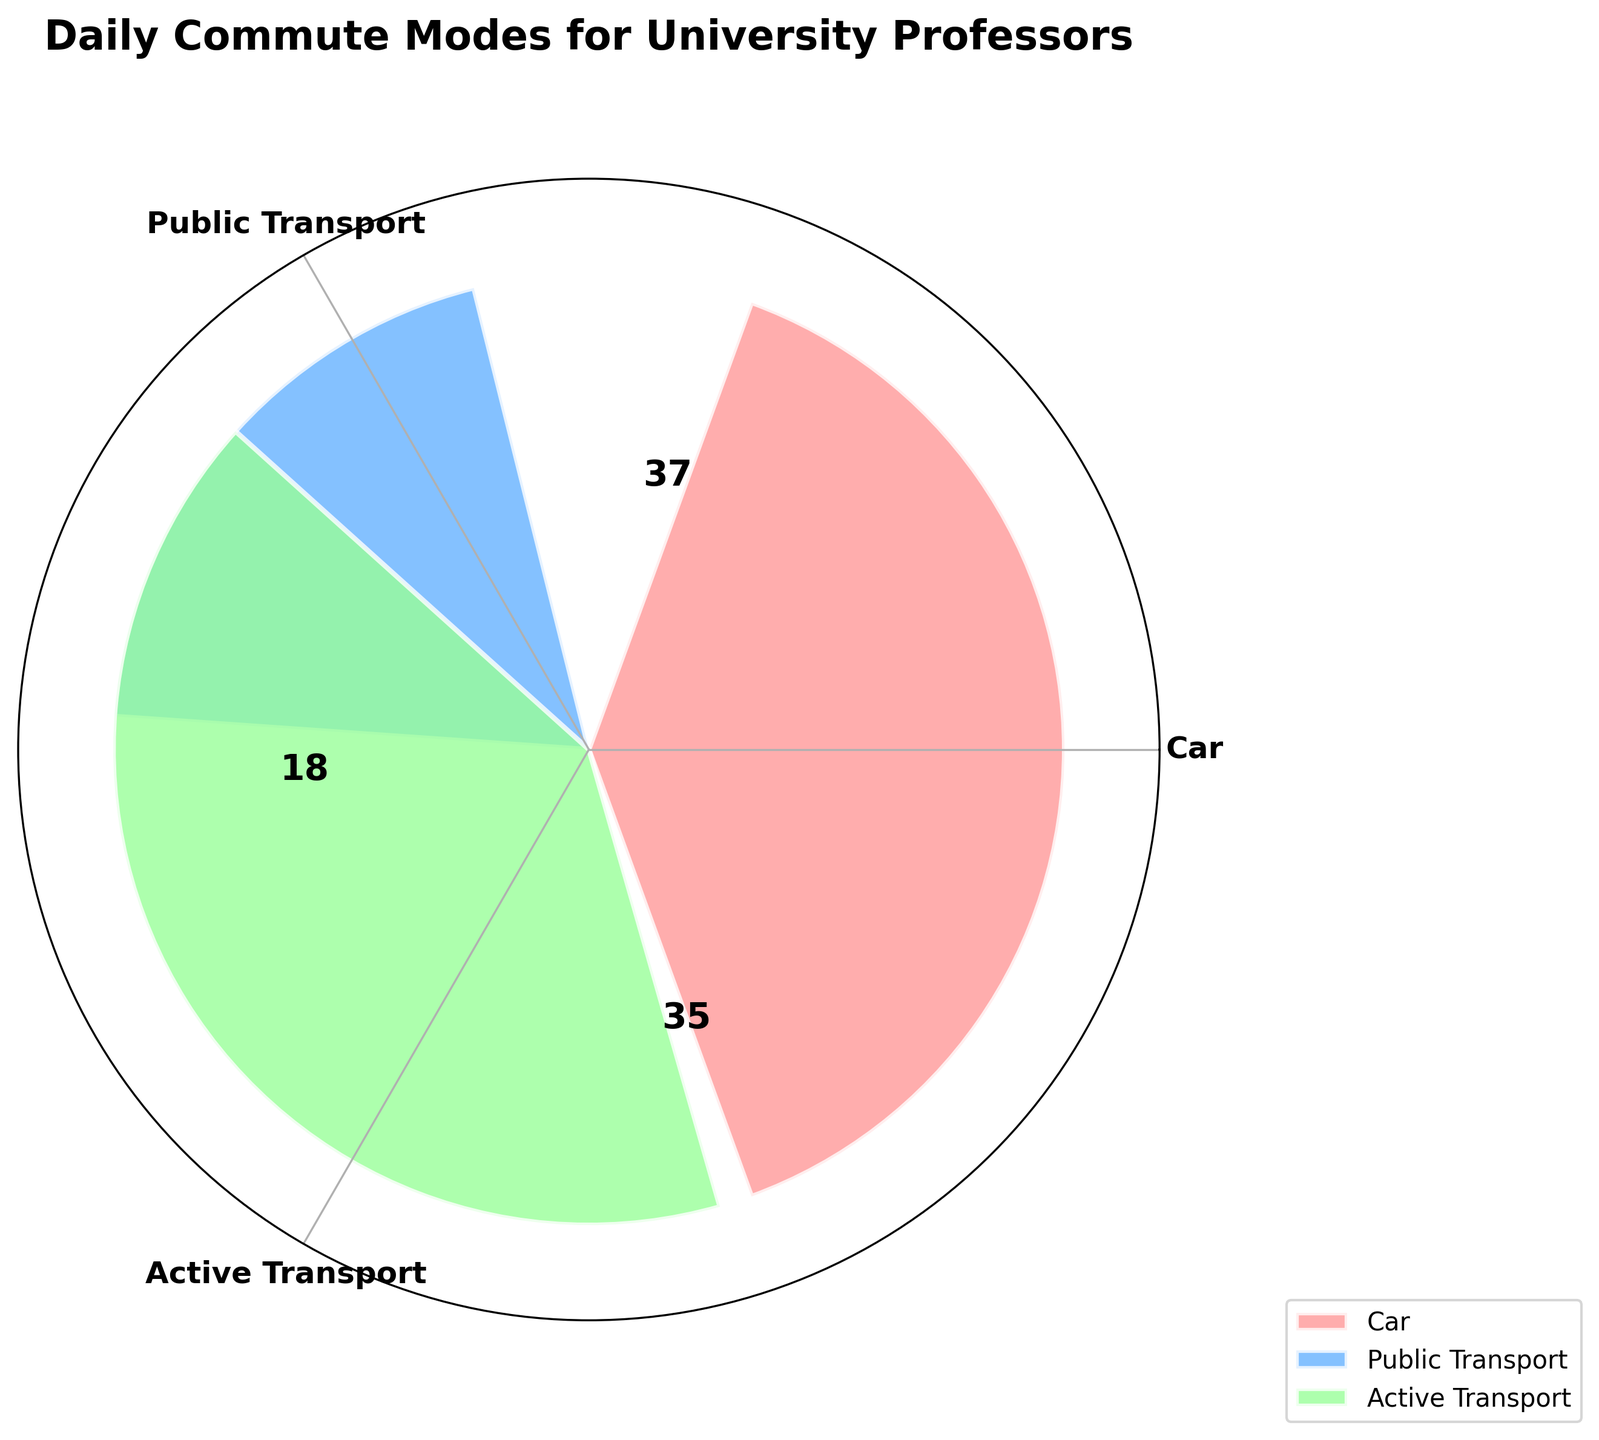What is the title of the plot? The title of the plot can be found at the top and reads "Daily Commute Modes for University Professors."
Answer: Daily Commute Modes for University Professors Which mode of transport has the highest frequency? The frequency for each mode is labeled within the plot. Car has the highest frequency labeled as '35.'
Answer: Car How many total professors commute via 'Active Transport'? The category 'Active Transport' combines Bike and Walking, which are labeled as 12 and 25 respectively. Summing them gives 12 + 25.
Answer: 37 What's the combined angle in radians for 'Active Transport' within the plot? The total frequency is 35 (Car) + 18 (Public Transport) + 37 (Active Transport) = 90. The angle for 'Active Transport' is calculated as 37/90 * 2π.
Answer: 2.59 radians Which mode of transport has the smallest slice in the polar plot? The mode with the smallest frequency will have the smallest slice. Public Transport has 18, which is smaller than Car (35) and Active Transport (37).
Answer: Public Transport Compare the number of professors using Public Transport with those using Active Transport. Which group is larger and by how many? Public Transport has 18, and Active Transport has 37. The difference is 37 - 18.
Answer: Active Transport; 19 more professors What is the order of modes from least to most frequently used? From the frequencies shown in the plot, we can see that Public Transport has 18, Active Transport has 37, and Car has 35. Ordering them gives Public Transport, Car, Active Transport.
Answer: Public Transport, Car, Active Transport How many unique modes of transport are represented in the plot? The plot labels three categories: Car, Public Transport, and Active Transport.
Answer: 3 What percentage of professors use Car for their commute? The frequency of professors using a Car is 35 out of the total 90. The percentage is (35/90) * 100.
Answer: 38.89% By how many degrees does the slice representing 'Car' exceed the slice for 'Public Transport'? The angle for Car is calculated as (35/90) * 360 degrees, and for Public Transport as (18/90) * 360 degrees. The difference is found by subtracting these values.
Answer: 68 degrees 